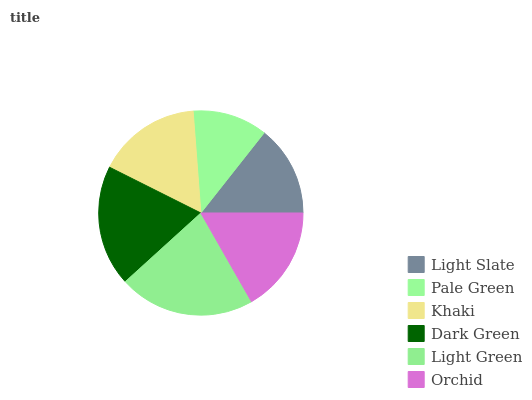Is Pale Green the minimum?
Answer yes or no. Yes. Is Light Green the maximum?
Answer yes or no. Yes. Is Khaki the minimum?
Answer yes or no. No. Is Khaki the maximum?
Answer yes or no. No. Is Khaki greater than Pale Green?
Answer yes or no. Yes. Is Pale Green less than Khaki?
Answer yes or no. Yes. Is Pale Green greater than Khaki?
Answer yes or no. No. Is Khaki less than Pale Green?
Answer yes or no. No. Is Orchid the high median?
Answer yes or no. Yes. Is Khaki the low median?
Answer yes or no. Yes. Is Light Slate the high median?
Answer yes or no. No. Is Pale Green the low median?
Answer yes or no. No. 